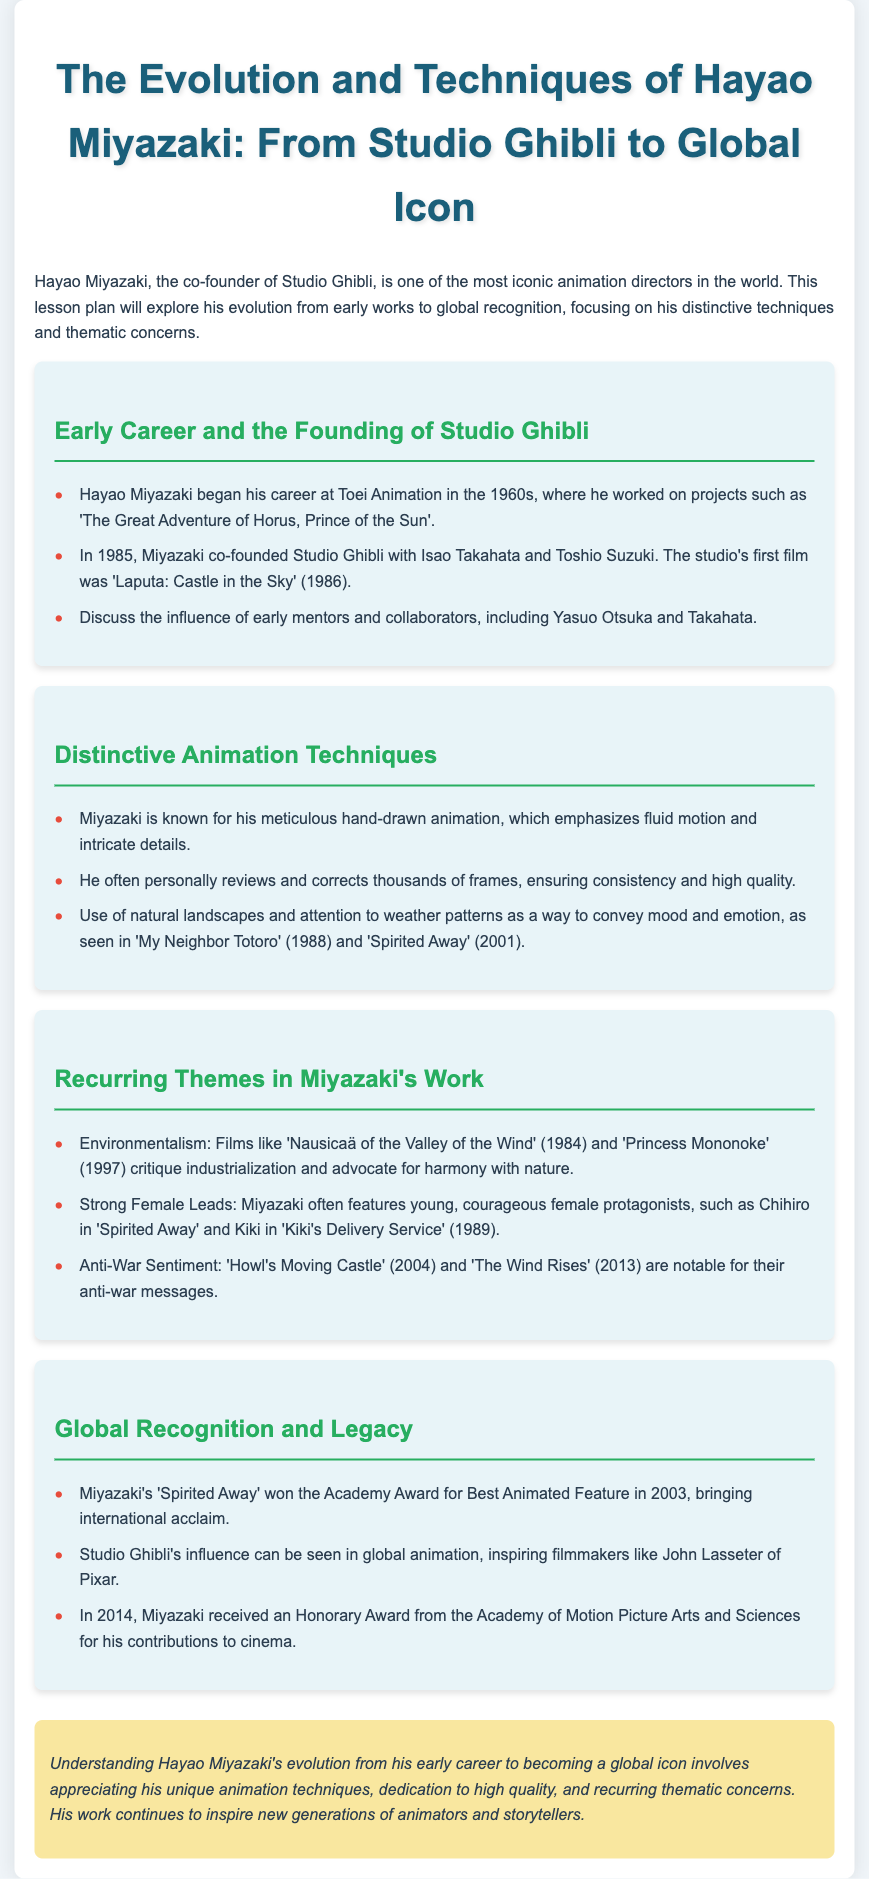What studio did Hayao Miyazaki co-found? The document states that Miyazaki co-founded Studio Ghibli.
Answer: Studio Ghibli In what year was 'Spirited Away' released? The document provides the release year for 'Spirited Away' as 2001.
Answer: 2001 Which film won the Academy Award for Best Animated Feature in 2003? The document mentions that 'Spirited Away' won the Academy Award for Best Animated Feature.
Answer: Spirited Away What is a common theme in Miyazaki's films? The document lists environmentalism as a common theme in Miyazaki's films.
Answer: Environmentalism Who is a notable strong female lead created by Miyazaki? The document cites Chihiro from 'Spirited Away' as a notable strong female lead.
Answer: Chihiro Which film is identified as Studio Ghibli's first? The document mentions that the studio's first film was 'Laputa: Castle in the Sky'.
Answer: Laputa: Castle in the Sky How many films are mentioned in the section on recurring themes? The document highlights three films in this section.
Answer: Three What animation technique is Miyazaki known for? The document indicates that Miyazaki is known for meticulous hand-drawn animation.
Answer: Hand-drawn animation What award did Miyazaki receive in 2014? The document says Miyazaki received an Honorary Award from the Academy.
Answer: Honorary Award 